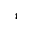Convert formula to latex. <formula><loc_0><loc_0><loc_500><loc_500>_ { 4 }</formula> 